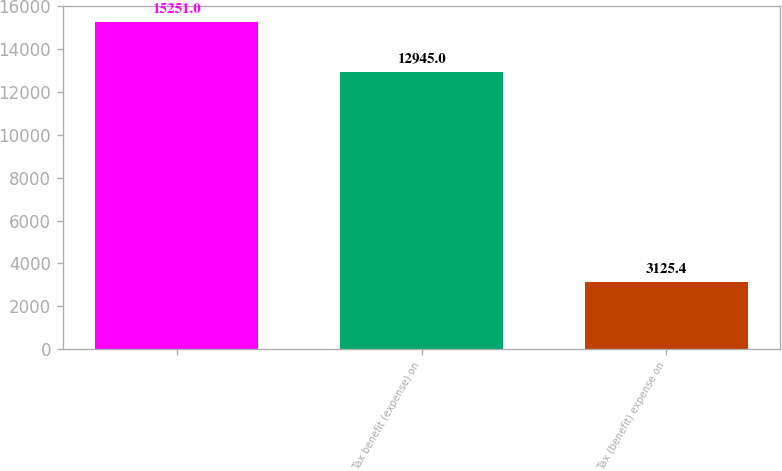<chart> <loc_0><loc_0><loc_500><loc_500><bar_chart><ecel><fcel>Tax benefit (expense) on<fcel>Tax (benefit) expense on<nl><fcel>15251<fcel>12945<fcel>3125.4<nl></chart> 